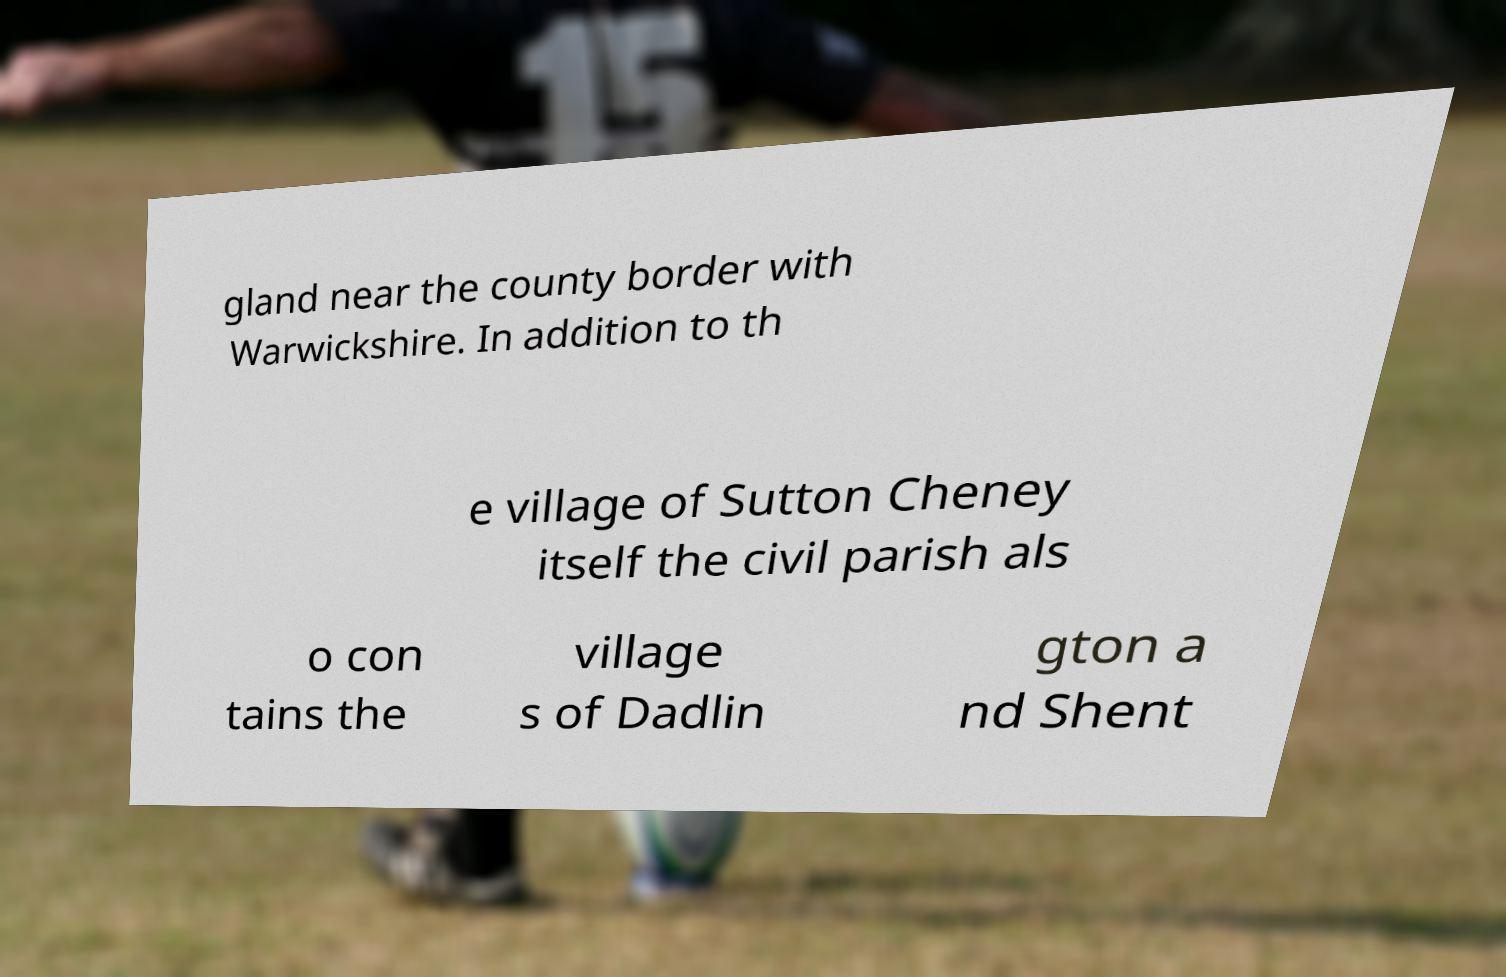I need the written content from this picture converted into text. Can you do that? gland near the county border with Warwickshire. In addition to th e village of Sutton Cheney itself the civil parish als o con tains the village s of Dadlin gton a nd Shent 